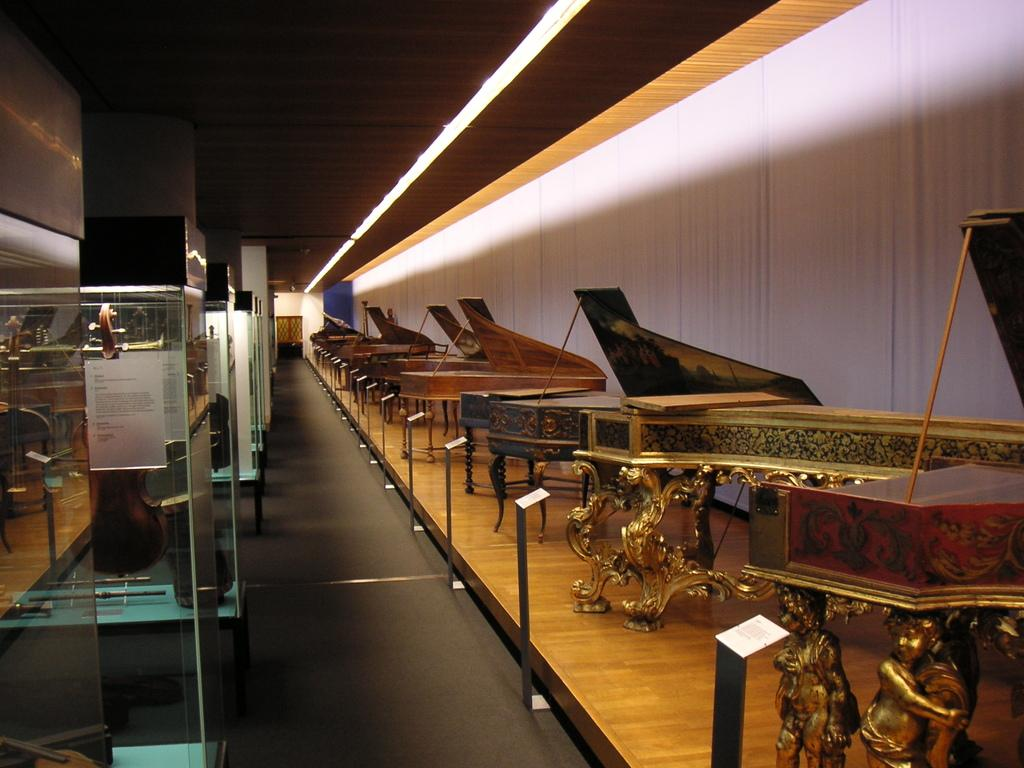What type of musical instruments are on the floor in the image? There is a group of pianos on the floor. What can be seen in the background of the image? There is a wall in the image. What can be used to provide illumination in the image? There are lights visible in the image. What type of fruit is being played on the pianos in the image? There are no fruits, including oranges, being played on the pianos in the image. 